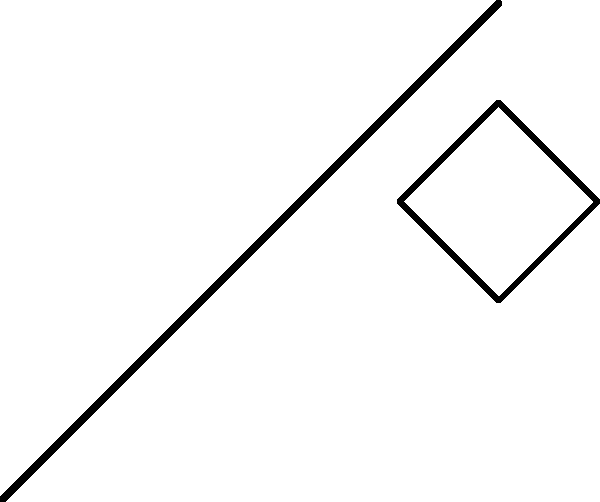When pruning a tree branch using shears, what is the primary biomechanical principle at work, and how does it affect the force required to make the cut? To understand the biomechanical forces involved in pruning, we need to consider the following steps:

1. Lever principle: The pruning shears act as a Class 1 lever, with the fulcrum at the pivot point between the two blades.

2. Force amplification: The handle of the pruning shears is longer than the blade section, creating a mechanical advantage. This amplifies the force applied by the gardener's hand.

3. Stress concentration: The blade of the pruning shears concentrates the force on a small area of the branch, increasing the pressure at the cutting point.

4. Shear stress: As the blades come together, they create a shearing force on the branch fibers. This force is perpendicular to the branch's length.

5. Fracture mechanics: The sharp blades initiate a crack in the branch material, which then propagates through the wood fibers.

6. Compression and tension: As the blades close, one side of the branch experiences compression while the other experiences tension, further facilitating the cut.

7. Wood structure: The cellular structure of the wood, including its grain direction, affects the resistance to cutting and the force required.

The primary biomechanical principle at work is the lever principle, which allows for force amplification. This means that a relatively small force applied by the gardener results in a much larger force at the cutting edge of the shears.

The force required to make the cut is reduced due to this mechanical advantage, making it easier for the gardener to prune even thick branches. The relationship between the input force (F1) and the output force (F2) can be expressed as:

$$F2 = F1 * \frac{d1}{d2}$$

Where d1 is the distance from the fulcrum to the handle end, and d2 is the distance from the fulcrum to the cutting edge.
Answer: Lever principle, reducing required force through mechanical advantage. 